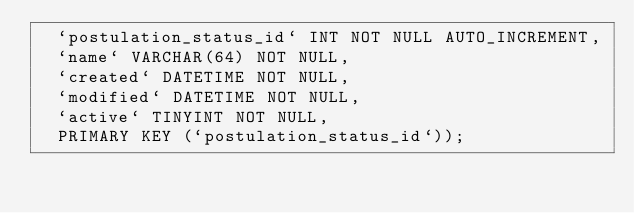Convert code to text. <code><loc_0><loc_0><loc_500><loc_500><_SQL_>  `postulation_status_id` INT NOT NULL AUTO_INCREMENT,
  `name` VARCHAR(64) NOT NULL,  
  `created` DATETIME NOT NULL,
  `modified` DATETIME NOT NULL,
  `active` TINYINT NOT NULL,
  PRIMARY KEY (`postulation_status_id`));
</code> 